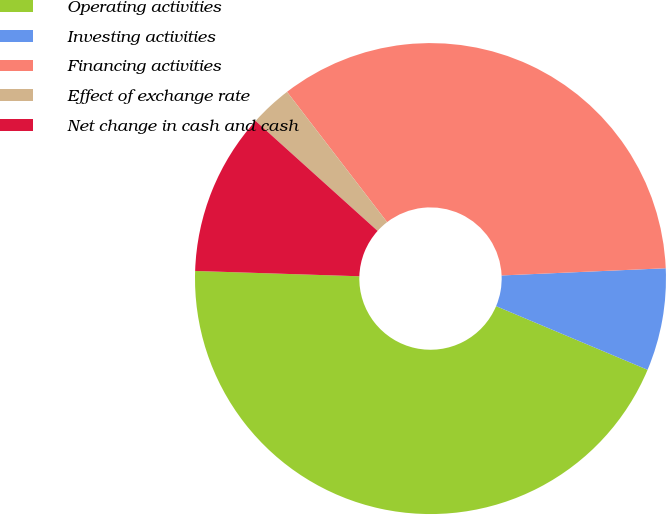Convert chart. <chart><loc_0><loc_0><loc_500><loc_500><pie_chart><fcel>Operating activities<fcel>Investing activities<fcel>Financing activities<fcel>Effect of exchange rate<fcel>Net change in cash and cash<nl><fcel>44.19%<fcel>7.03%<fcel>34.73%<fcel>2.9%<fcel>11.16%<nl></chart> 